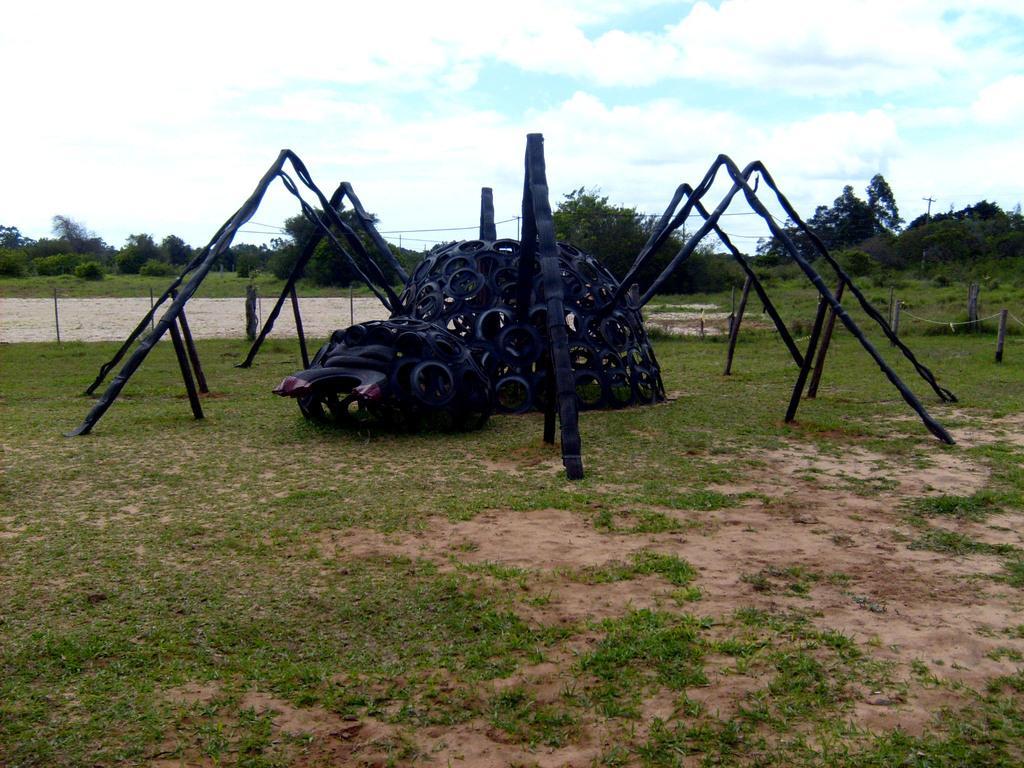Can you describe this image briefly? In the foreground of this image, there are few objects and it seems like There are placed on the ground as a spider structure. In the background, there are poles, trees and the sky. 